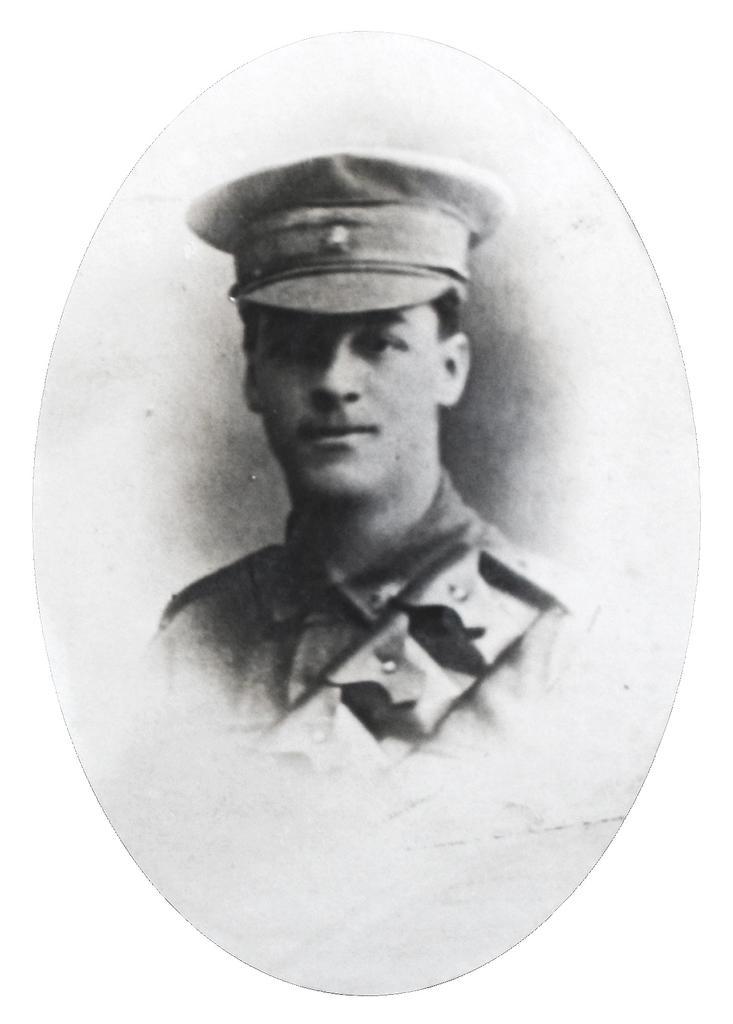How would you summarize this image in a sentence or two? In this image we can see the photo frame of a policeman. 